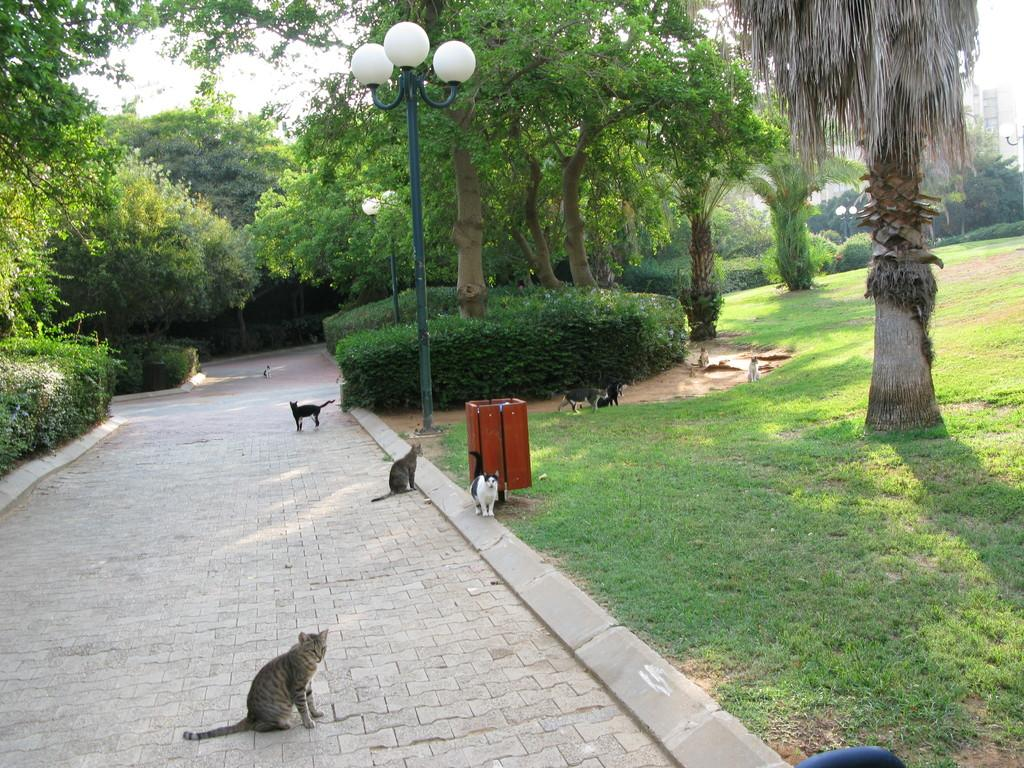What animals are present in the image? There are cats in the image. Where are the cats located in the image? The cats are on a path or way in the image. What can be seen on either side of the path or way? There are plants and trees on either side of the path or way. What type of book is the cat reading on the path? There is no book present in the image; the cats are simply on the path or way. 